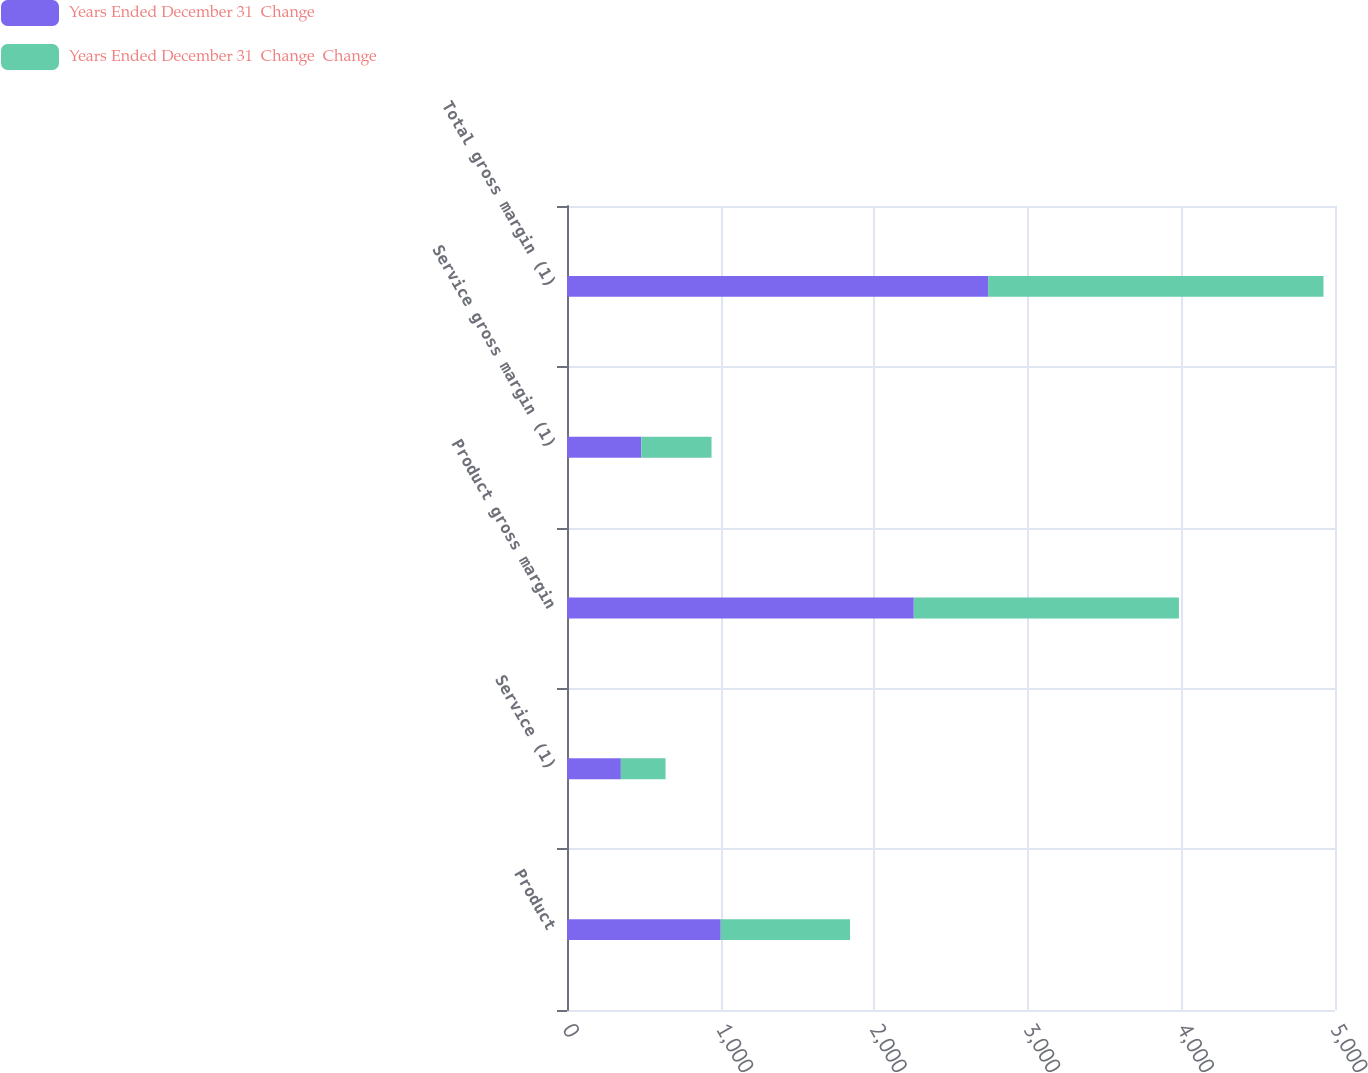Convert chart. <chart><loc_0><loc_0><loc_500><loc_500><stacked_bar_chart><ecel><fcel>Product<fcel>Service (1)<fcel>Product gross margin<fcel>Service gross margin (1)<fcel>Total gross margin (1)<nl><fcel>Years Ended December 31  Change<fcel>1000.9<fcel>350.6<fcel>2257.8<fcel>484<fcel>2741.8<nl><fcel>Years Ended December 31  Change  Change<fcel>841.7<fcel>291<fcel>1726.3<fcel>456.9<fcel>2183.2<nl></chart> 